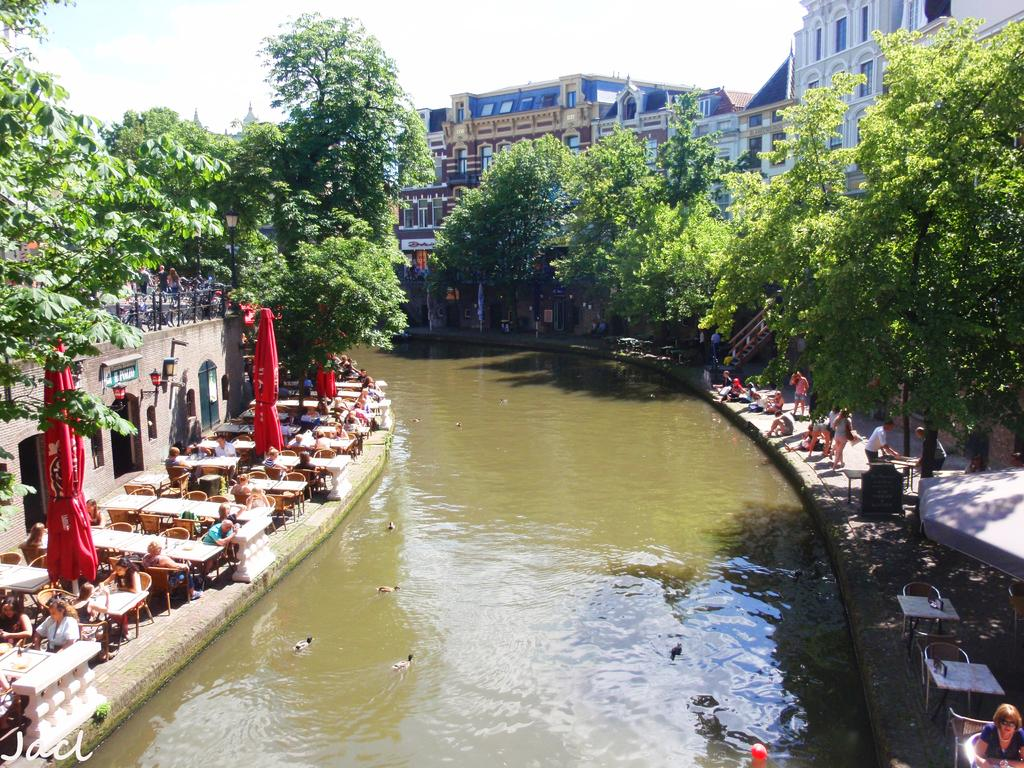What are the people in the image doing? The people in the image are sitting around tables. What can be seen in the foreground of the image? There is water in the foreground area of the image. What is visible in the background of the image? There are trees, buildings, and the sky visible in the background of the image. What type of business is being conducted by the boy in the image? There is no boy present in the image, and no business is being conducted. 